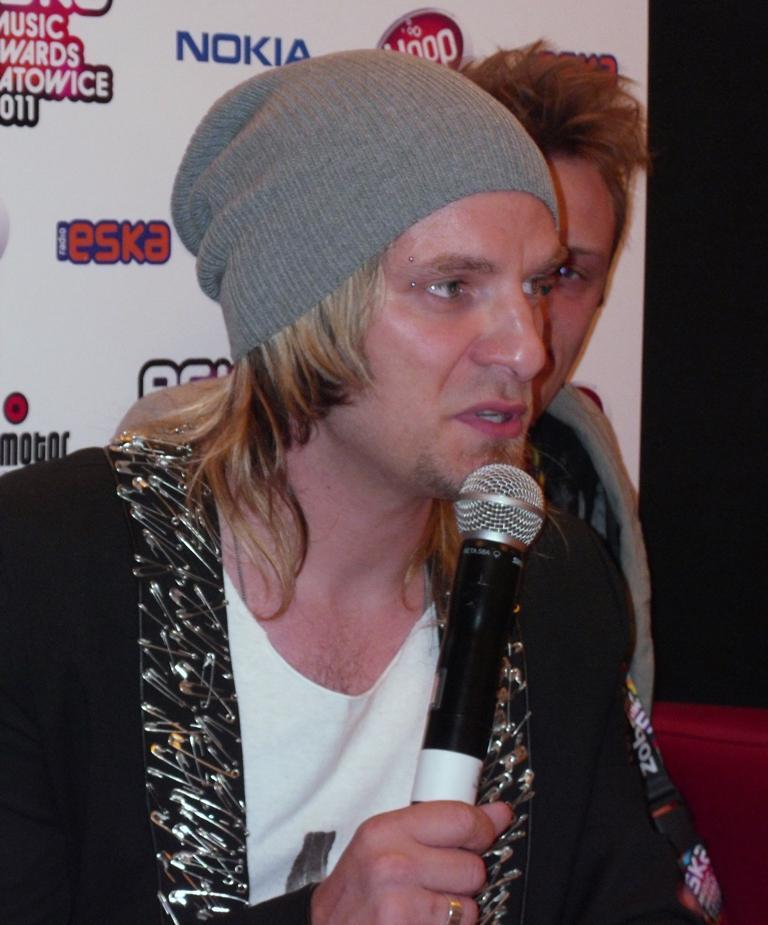Who is present in the image? There is a man in the image. What is the man wearing on his head? The man is wearing a cap. What is the man holding in his hand? The man is holding a microphone in his hand. Who is the man looking at? The man is looking at someone. Can you describe the presence of another person in the image? There is another person in the background of the image. What is the name of the man's daughter in the image? There is no mention of a daughter in the image, and therefore no name can be provided. 